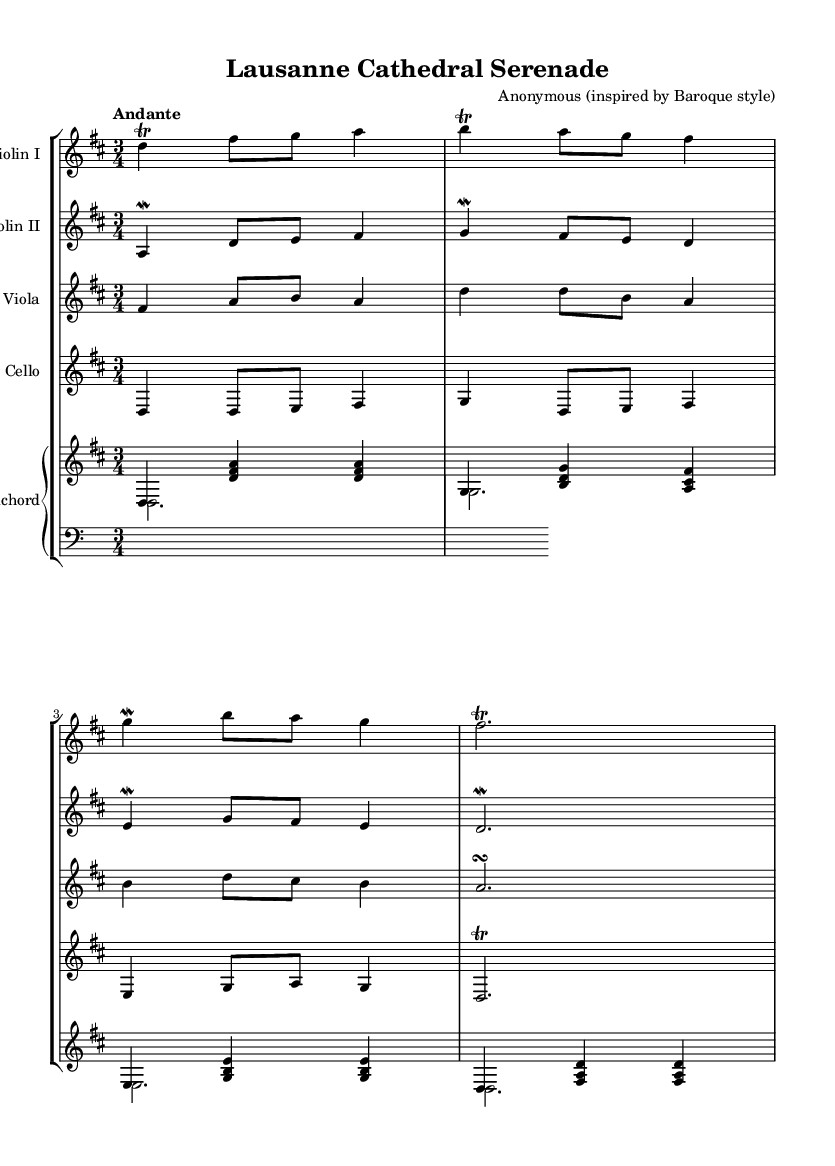What is the key signature of this music? The key signature is indicated at the beginning of the score, showing two sharps which corresponds to D major.
Answer: D major What is the time signature of this music? The time signature is found at the start of the music, represented by a 3 over a 4, indicating three beats per measure.
Answer: 3/4 What is the tempo marking of this piece? The tempo marking is found in the first line of the score, indicating "Andante", which signifies a moderate walking pace.
Answer: Andante How many instruments are in this chamber music? The score shows five staves, indicating five instruments: two violins, one viola, one cello, and one harpsichord.
Answer: Five Which instrument plays the lowest part? By examining the staves from top to bottom, the cello staff is the lowest, indicating it plays the lowest pitch in this ensemble.
Answer: Cello What is the role of the harpsichord in this piece? The harpsichord is indicated to play both a harmonic and rhythmic role, supporting the string instruments with chords and a bass part.
Answer: Harmonic support How many measures are in the first line of music for the violin I? By counting the distinct groupings of the notes and rests in the first line specifically for violin I, there are four measures.
Answer: Four 